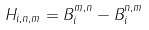<formula> <loc_0><loc_0><loc_500><loc_500>H _ { i , n , m } = B ^ { m , n } _ { i } - B ^ { n , m } _ { i }</formula> 